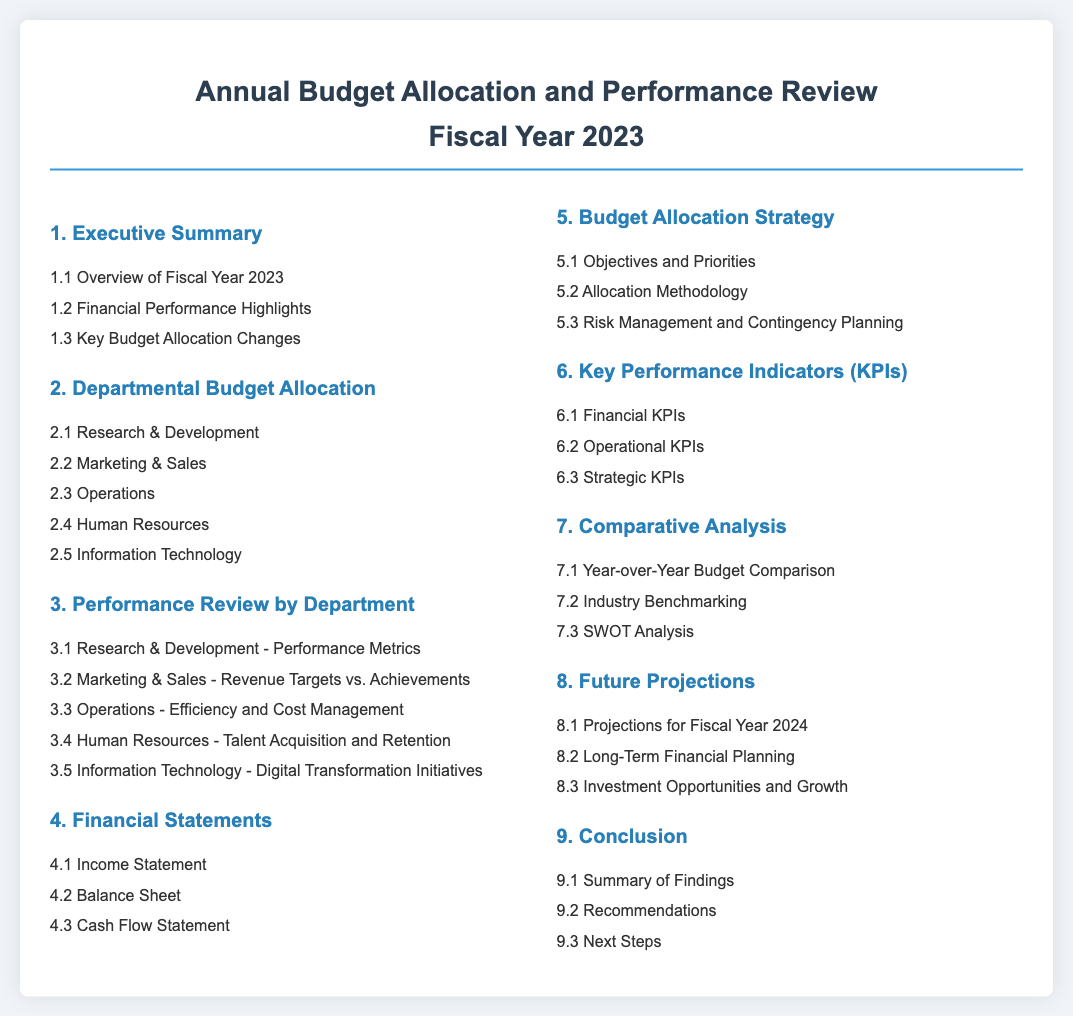what is the title of the document? The title of the document is prominently displayed at the top of the page, indicating the focus on annual budget and performance review.
Answer: Annual Budget Allocation and Performance Review Fiscal Year 2023 how many sections are in the Table of Contents? The Table of Contents consists of numbered sections, where each number corresponds to a distinct section addressing various topics.
Answer: 9 which department has a section about performance metrics? The document specifies different departments and their evaluation metrics under the performance review section.
Answer: Research & Development what is the objective of the budget allocation strategy? The objectives and priorities for budget allocation are outlined in one of the sections to provide direction for resource distribution.
Answer: Objectives and Priorities what is the first financial statement listed? The list of financial statements presents various crucial documents necessary for understanding the financial health.
Answer: Income Statement what type of analysis is included for comparison? The document conducts a detailed examination against established benchmarks and past performances to evaluate effectiveness.
Answer: SWOT Analysis how many KPIs are listed in the document? The document categorizes key performance indicators into several types that are essential for assessing performance against targets.
Answer: 3 what are the projections for the upcoming fiscal year? Future projections provide insights and expectations based on current performance and strategies that inform planning for the next fiscal cycle.
Answer: Projections for Fiscal Year 2024 what type of summary is included at the conclusion? The conclusion section summarizes major findings and offers recommendations for future actions based on the review performed.
Answer: Summary of Findings 